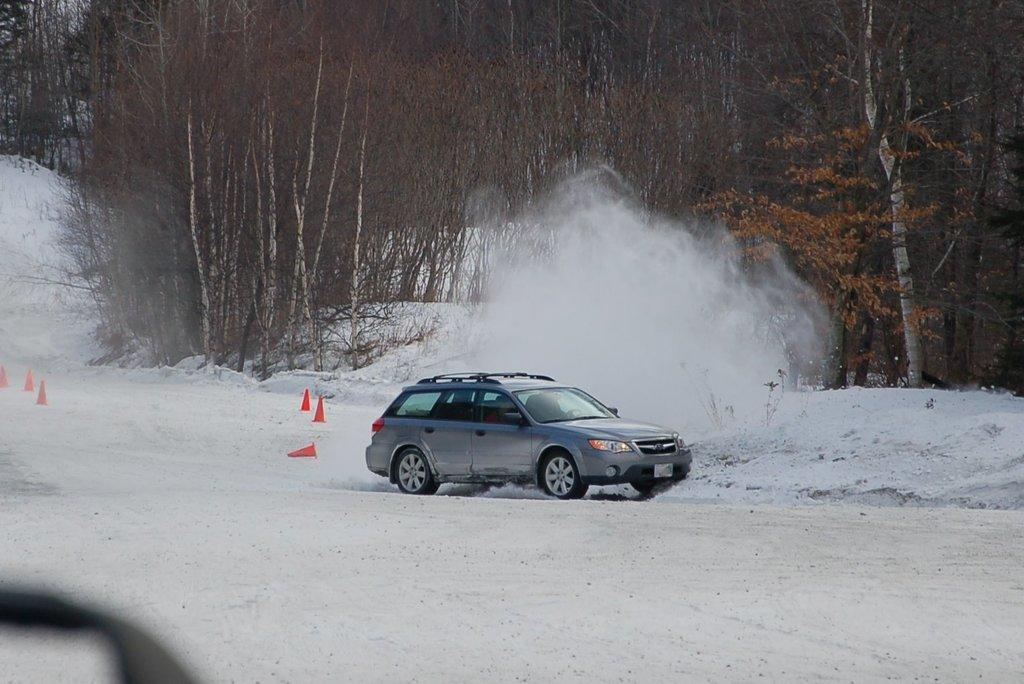Could you give a brief overview of what you see in this image? In this image there is car in the center. In the background there are trees and on the ground there is snow. 